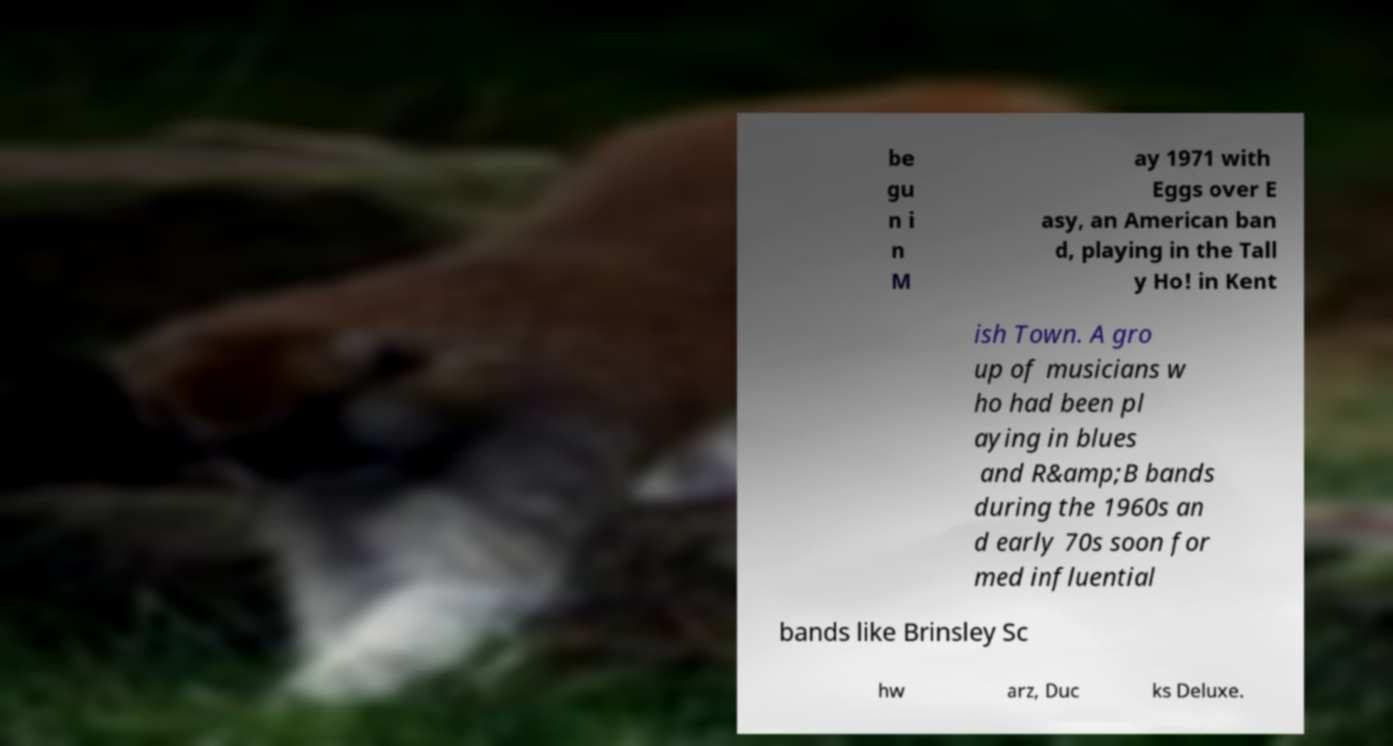Could you extract and type out the text from this image? be gu n i n M ay 1971 with Eggs over E asy, an American ban d, playing in the Tall y Ho! in Kent ish Town. A gro up of musicians w ho had been pl aying in blues and R&amp;B bands during the 1960s an d early 70s soon for med influential bands like Brinsley Sc hw arz, Duc ks Deluxe. 